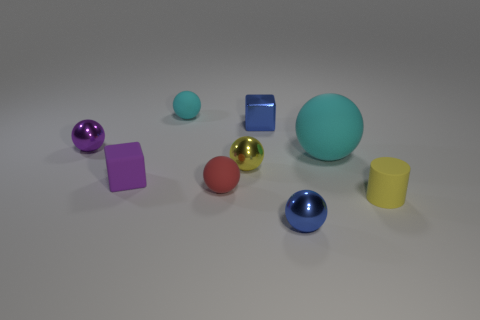Subtract all cyan balls. How many balls are left? 4 Add 1 big purple rubber balls. How many objects exist? 10 Subtract all purple balls. How many balls are left? 5 Subtract all gray cubes. How many cyan balls are left? 2 Subtract 1 spheres. How many spheres are left? 5 Subtract all blocks. How many objects are left? 7 Subtract all tiny purple rubber things. Subtract all large rubber things. How many objects are left? 7 Add 5 tiny yellow rubber objects. How many tiny yellow rubber objects are left? 6 Add 4 small purple matte spheres. How many small purple matte spheres exist? 4 Subtract 0 cyan blocks. How many objects are left? 9 